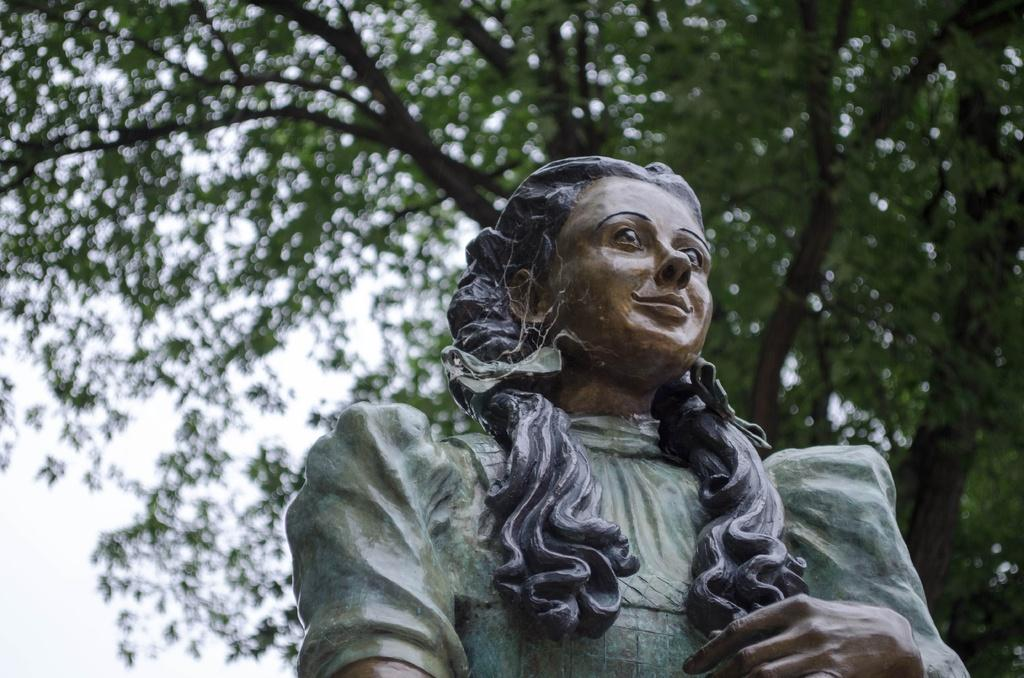What is the main subject of the image? There is a statue in the shape of a woman in the image. What type of vegetation can be seen in the image? There are trees in the image. What type of branch is the woman using to cut the scissors in the image? There is no branch, scissors, or cutting action present in the image. 